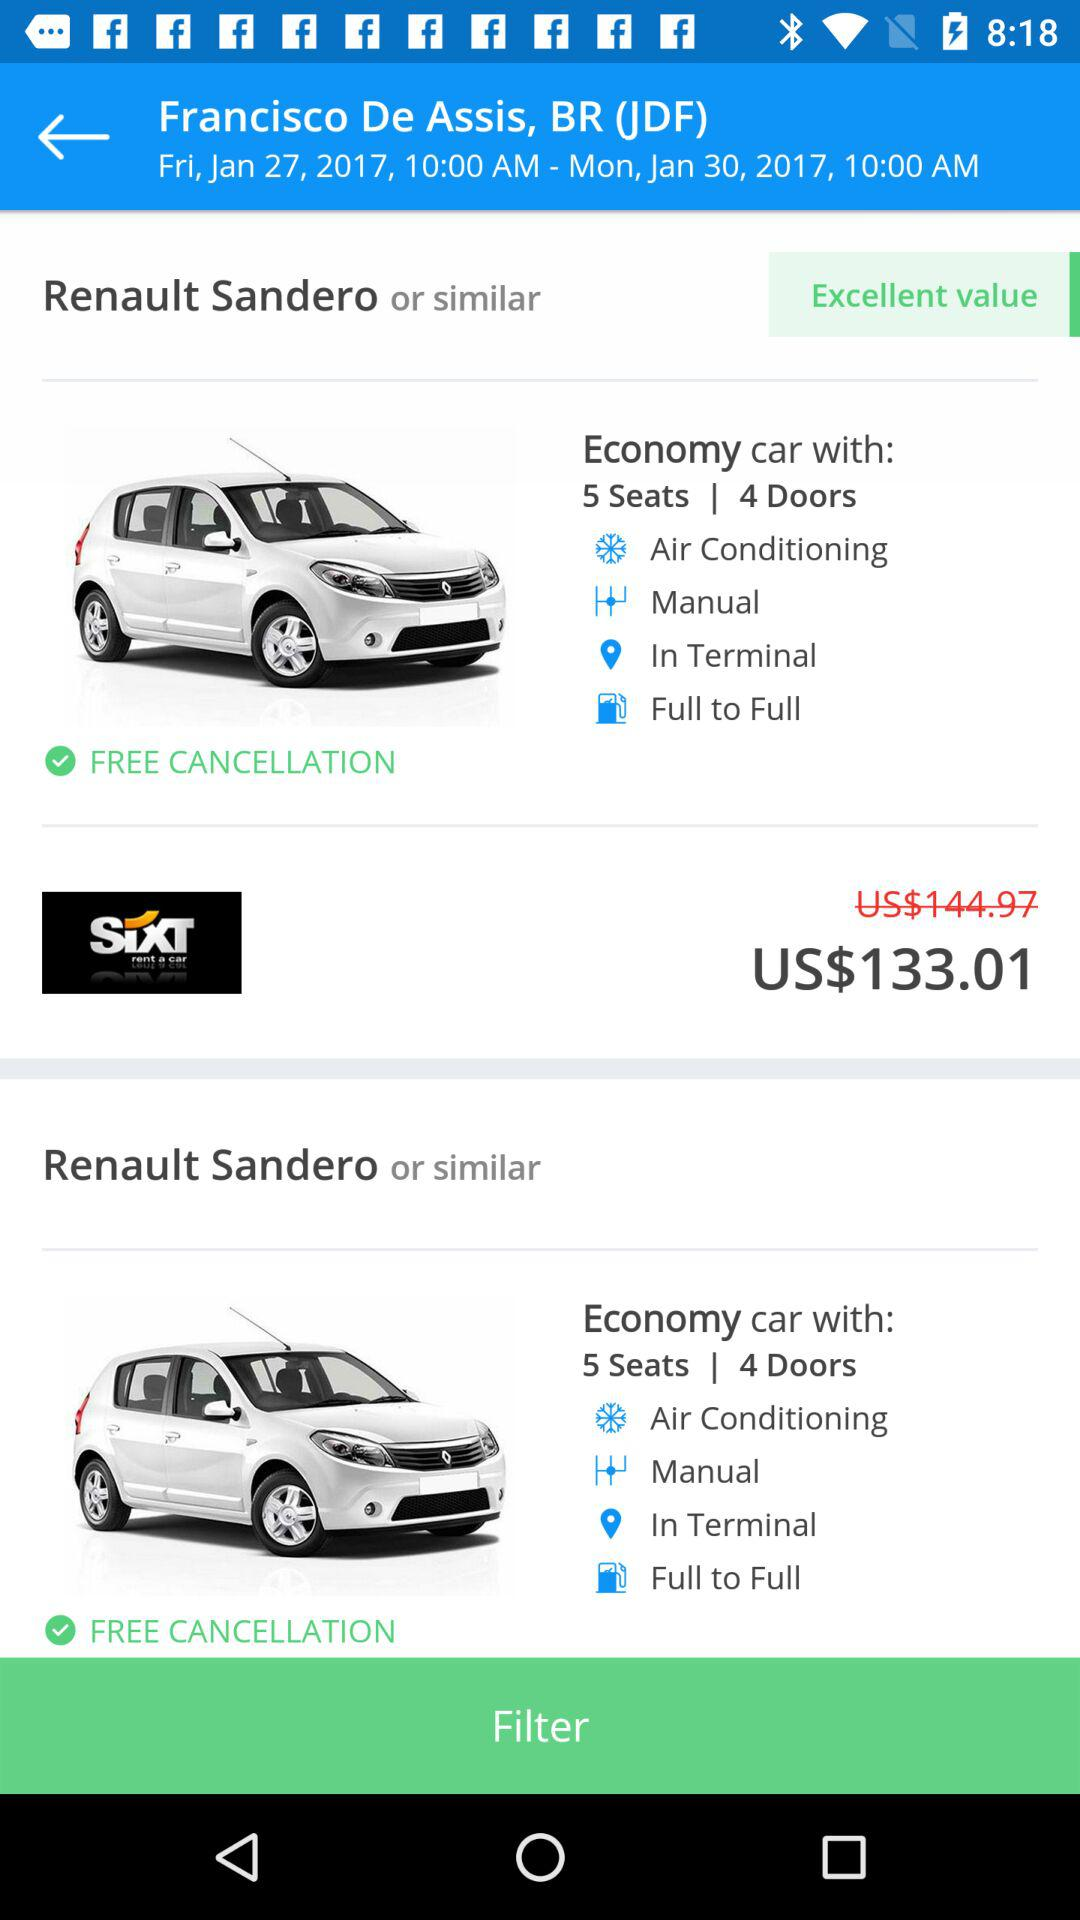How many seats are in the car? There are 5 seats in the car. 